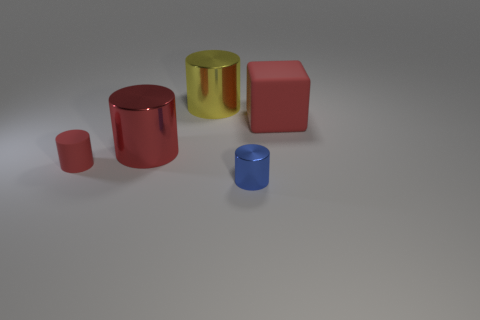Add 1 large things. How many objects exist? 6 Subtract all blue shiny cylinders. How many cylinders are left? 3 Subtract 2 cylinders. How many cylinders are left? 2 Subtract all blue cylinders. How many cylinders are left? 3 Subtract all large blue spheres. Subtract all large shiny objects. How many objects are left? 3 Add 4 small cylinders. How many small cylinders are left? 6 Add 4 large rubber objects. How many large rubber objects exist? 5 Subtract 0 purple cylinders. How many objects are left? 5 Subtract all blocks. How many objects are left? 4 Subtract all cyan cylinders. Subtract all blue spheres. How many cylinders are left? 4 